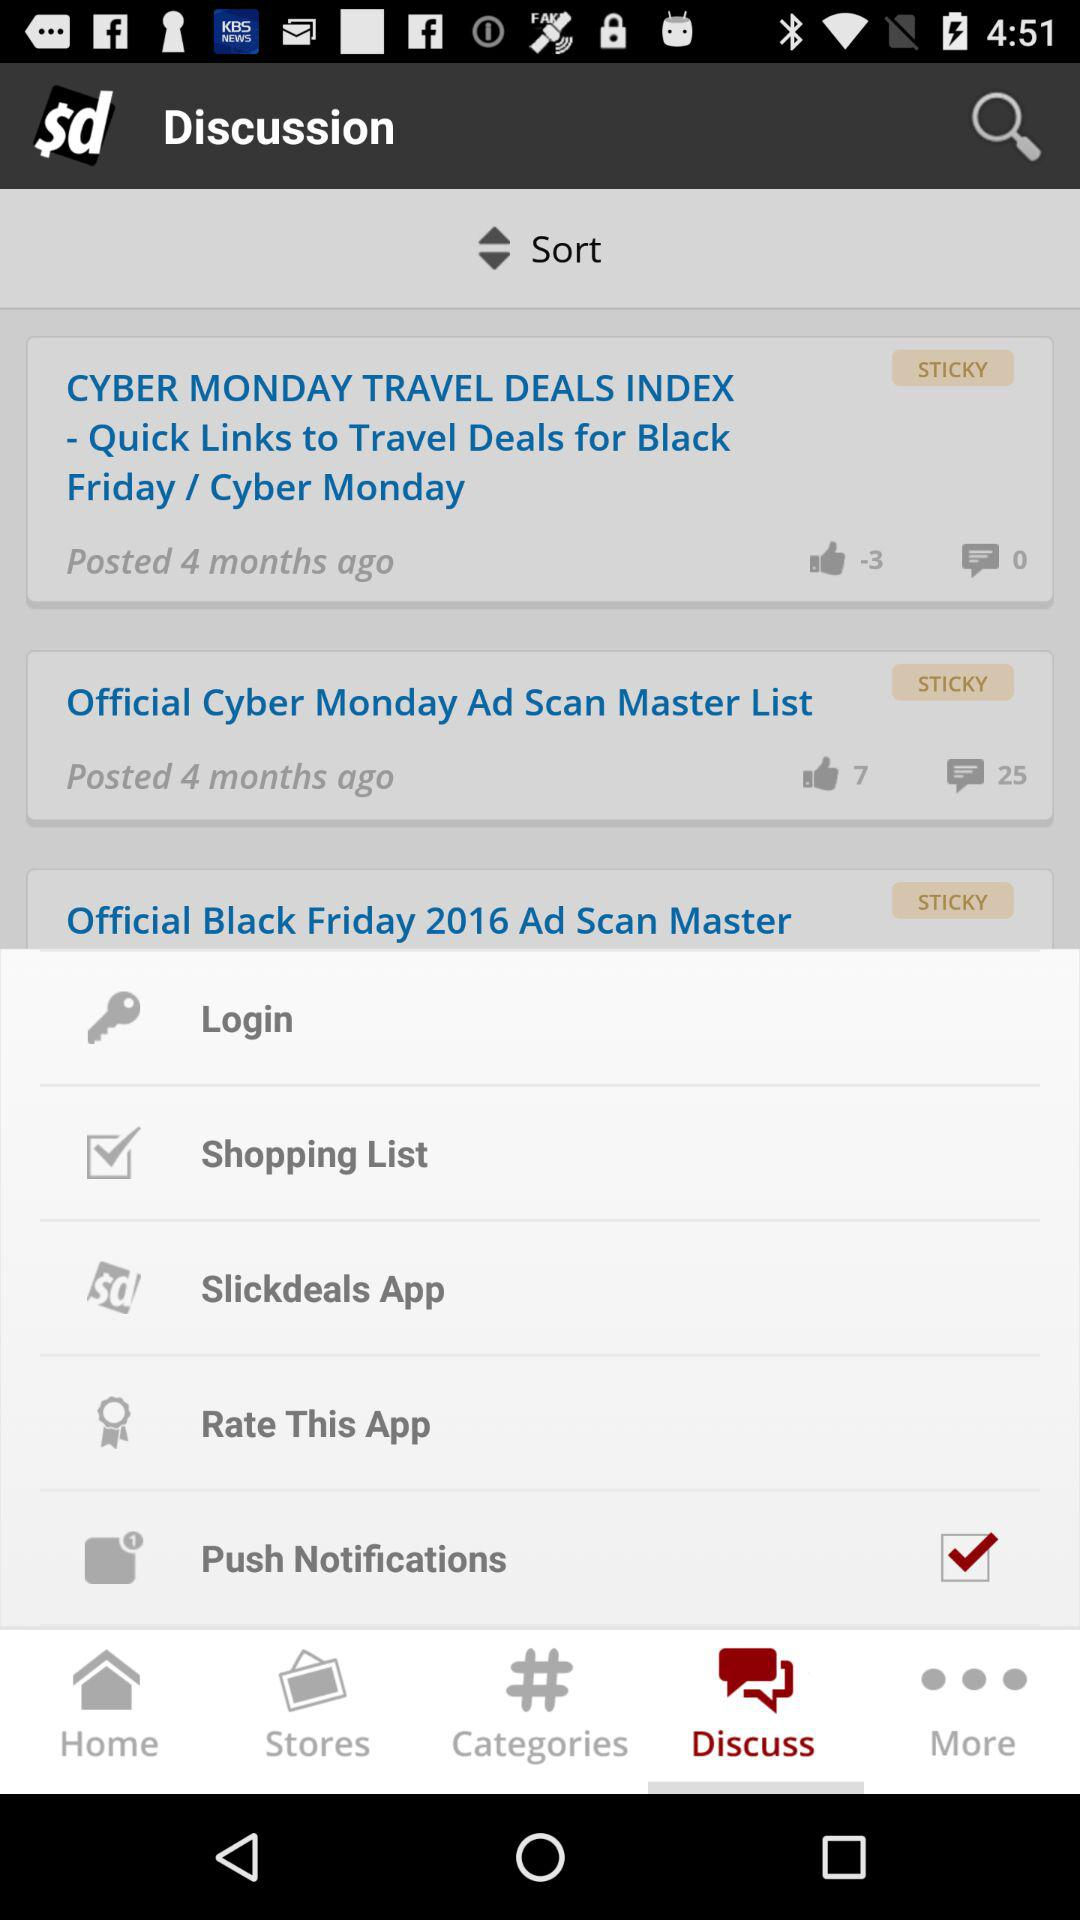What is the count of likes on "CYBER MONDAY TRAVEL DEALS INDEX - Quick Links to Travel Deals for Black Friday / Cyber Monday"? The count of likes on "CYBER MONDAY TRAVEL DEALS INDEX - Quick Links to Travel Deals for Black Friday / Cyber Monday" is -3. 